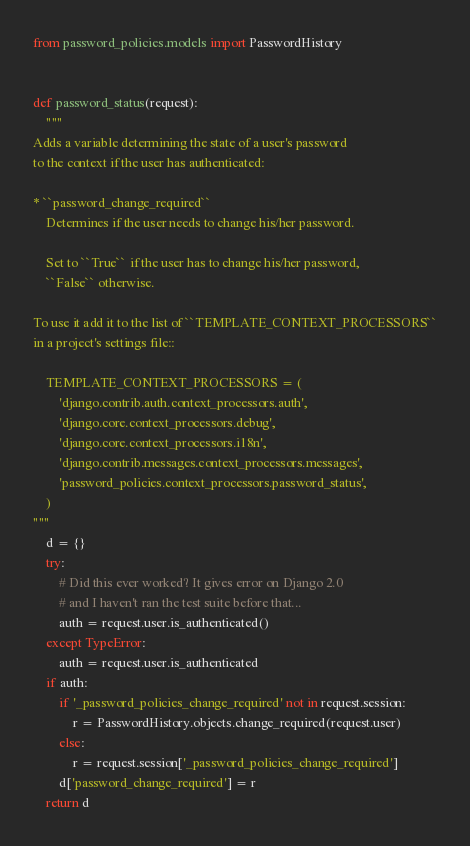<code> <loc_0><loc_0><loc_500><loc_500><_Python_>from password_policies.models import PasswordHistory


def password_status(request):
    """
Adds a variable determining the state of a user's password
to the context if the user has authenticated:

* ``password_change_required``
    Determines if the user needs to change his/her password.

    Set to ``True`` if the user has to change his/her password,
    ``False`` otherwise.

To use it add it to the list of ``TEMPLATE_CONTEXT_PROCESSORS``
in a project's settings file::

    TEMPLATE_CONTEXT_PROCESSORS = (
        'django.contrib.auth.context_processors.auth',
        'django.core.context_processors.debug',
        'django.core.context_processors.i18n',
        'django.contrib.messages.context_processors.messages',
        'password_policies.context_processors.password_status',
    )
"""
    d = {}
    try:
        # Did this ever worked? It gives error on Django 2.0
        # and I haven't ran the test suite before that...
        auth = request.user.is_authenticated()
    except TypeError:
        auth = request.user.is_authenticated
    if auth:
        if '_password_policies_change_required' not in request.session:
            r = PasswordHistory.objects.change_required(request.user)
        else:
            r = request.session['_password_policies_change_required']
        d['password_change_required'] = r
    return d
</code> 